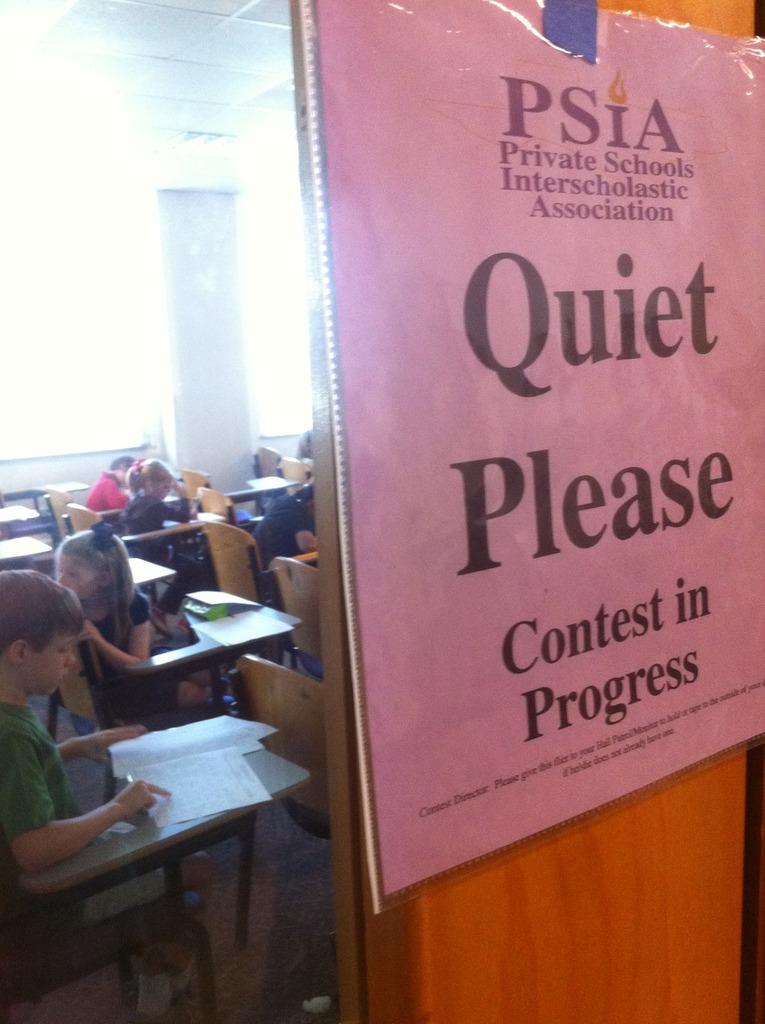What is in progress?
Provide a succinct answer. Contest. 